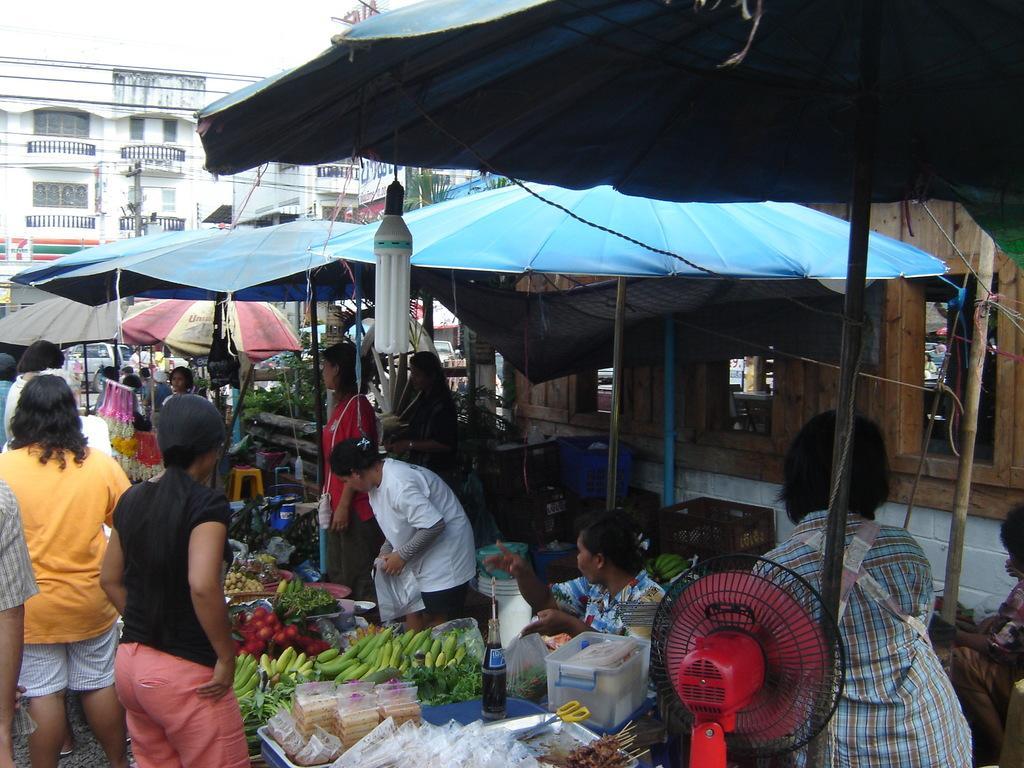How would you summarize this image in a sentence or two? In this picture we can observe some people standing in front of the stalls in the market. We can observe blue color fabric roofs here. There is a light hanging. We can observe a red color table fan. There are some vegetables and fruits. In the background there is a white color building and a sky. 